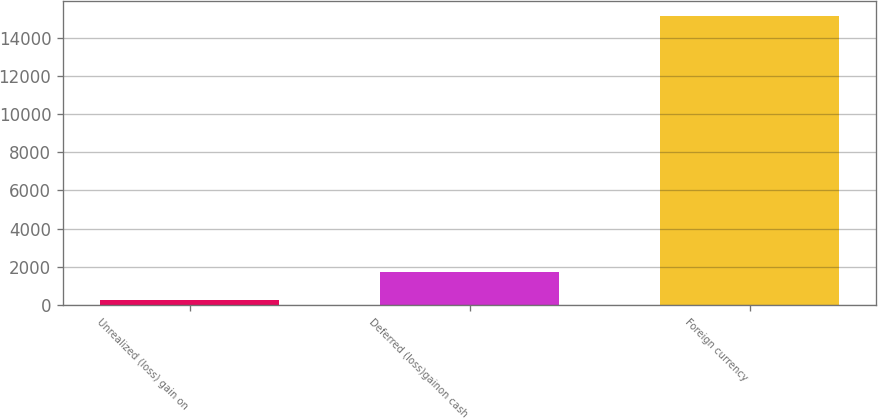<chart> <loc_0><loc_0><loc_500><loc_500><bar_chart><fcel>Unrealized (loss) gain on<fcel>Deferred (loss)gainon cash<fcel>Foreign currency<nl><fcel>250<fcel>1740.9<fcel>15159<nl></chart> 